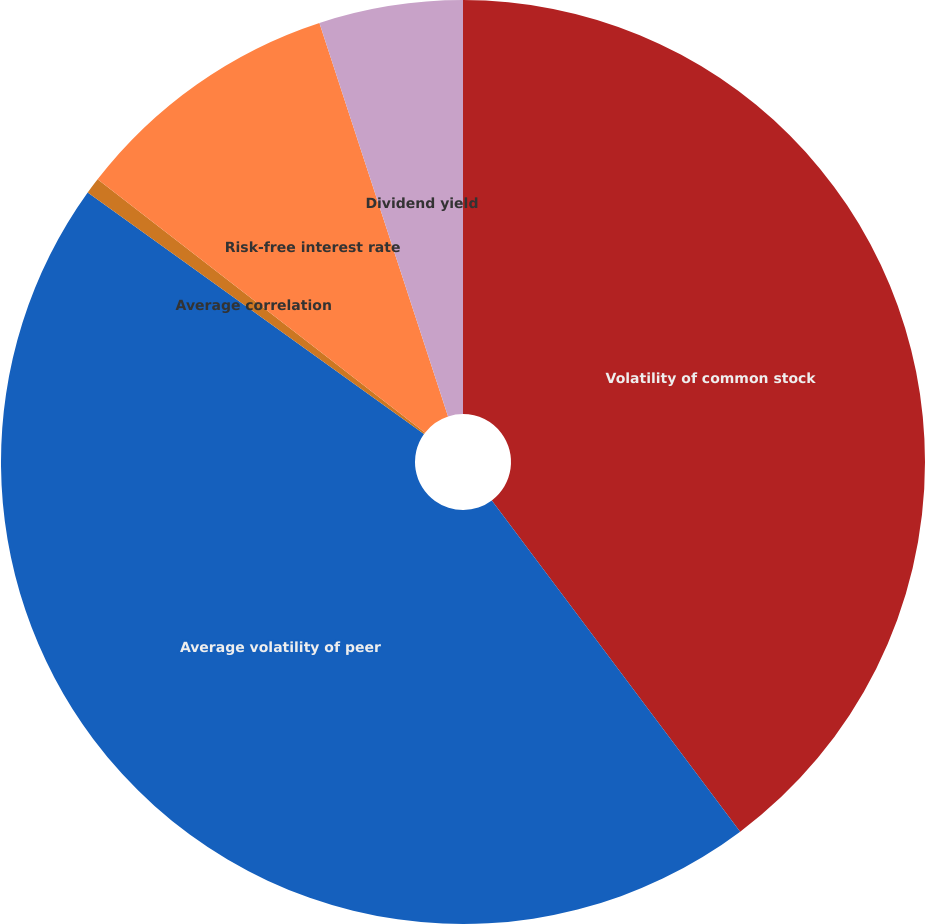<chart> <loc_0><loc_0><loc_500><loc_500><pie_chart><fcel>Volatility of common stock<fcel>Average volatility of peer<fcel>Average correlation<fcel>Risk-free interest rate<fcel>Dividend yield<nl><fcel>39.76%<fcel>45.15%<fcel>0.57%<fcel>9.49%<fcel>5.03%<nl></chart> 